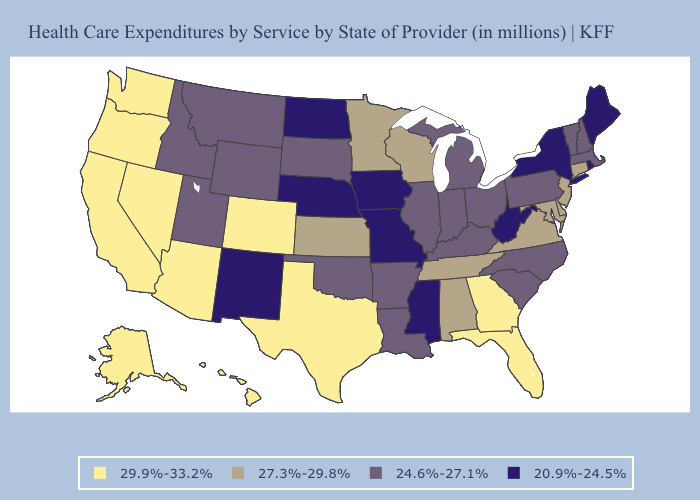Name the states that have a value in the range 27.3%-29.8%?
Keep it brief. Alabama, Connecticut, Delaware, Kansas, Maryland, Minnesota, New Jersey, Tennessee, Virginia, Wisconsin. Among the states that border Texas , which have the highest value?
Write a very short answer. Arkansas, Louisiana, Oklahoma. What is the value of Illinois?
Quick response, please. 24.6%-27.1%. Name the states that have a value in the range 24.6%-27.1%?
Short answer required. Arkansas, Idaho, Illinois, Indiana, Kentucky, Louisiana, Massachusetts, Michigan, Montana, New Hampshire, North Carolina, Ohio, Oklahoma, Pennsylvania, South Carolina, South Dakota, Utah, Vermont, Wyoming. Among the states that border Wyoming , which have the highest value?
Answer briefly. Colorado. What is the highest value in the USA?
Be succinct. 29.9%-33.2%. Among the states that border Virginia , does Tennessee have the lowest value?
Keep it brief. No. What is the highest value in states that border Alabama?
Write a very short answer. 29.9%-33.2%. Name the states that have a value in the range 27.3%-29.8%?
Short answer required. Alabama, Connecticut, Delaware, Kansas, Maryland, Minnesota, New Jersey, Tennessee, Virginia, Wisconsin. What is the highest value in the USA?
Quick response, please. 29.9%-33.2%. What is the highest value in the USA?
Concise answer only. 29.9%-33.2%. Among the states that border South Carolina , does North Carolina have the highest value?
Concise answer only. No. Which states hav the highest value in the MidWest?
Write a very short answer. Kansas, Minnesota, Wisconsin. What is the value of Illinois?
Write a very short answer. 24.6%-27.1%. Does West Virginia have the lowest value in the USA?
Keep it brief. Yes. 